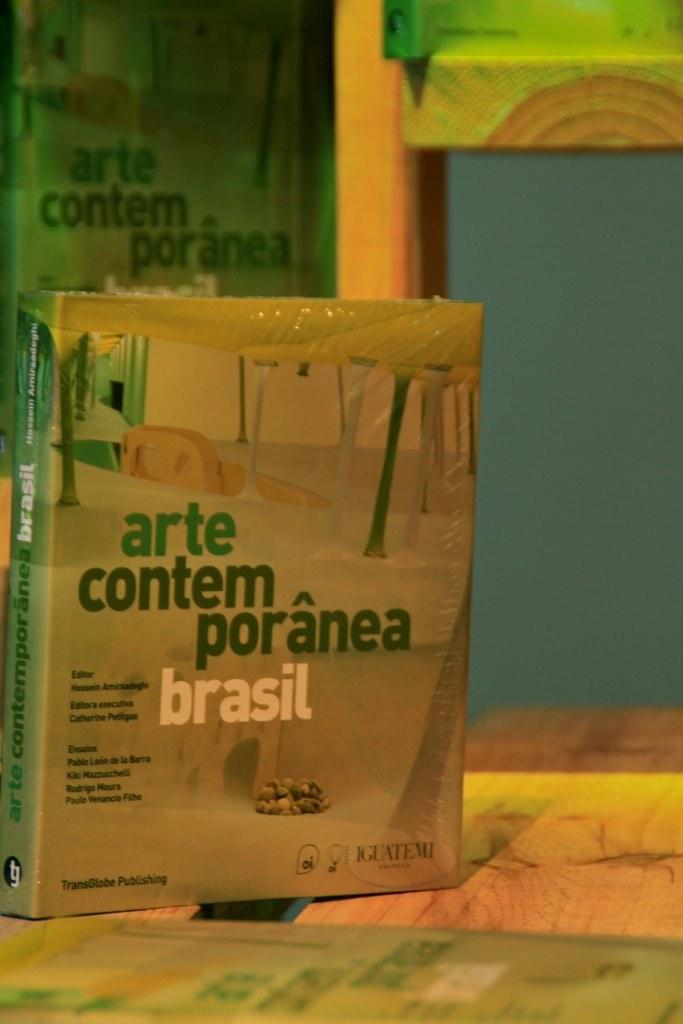Where is this product from?
Make the answer very short. Brasil. 